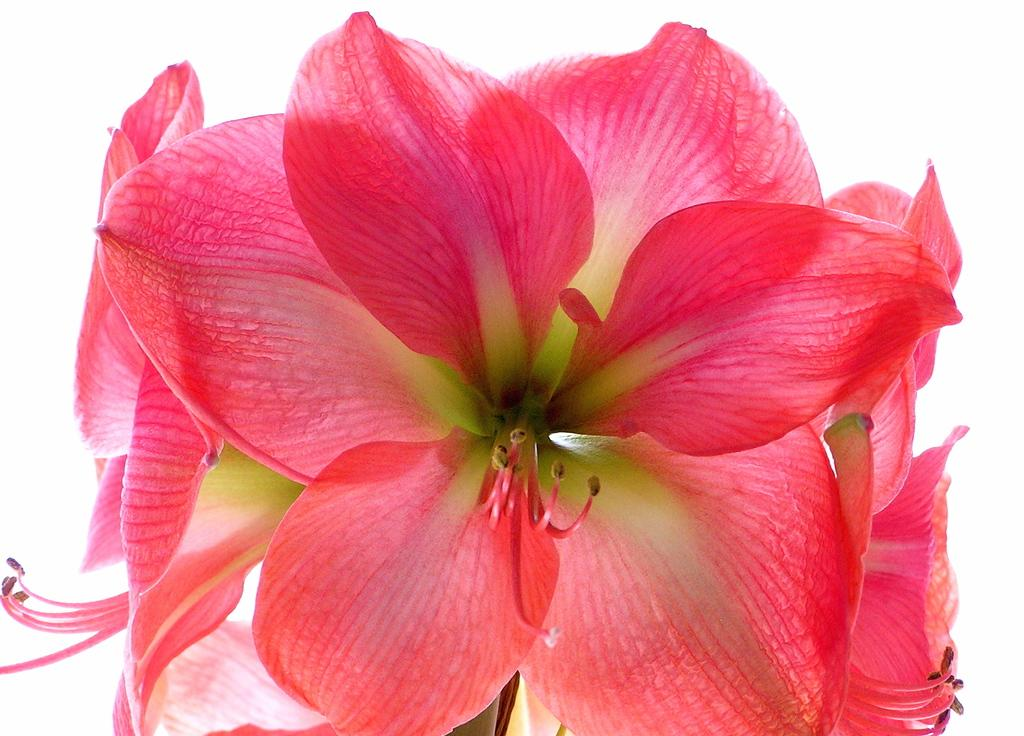What type of plants can be seen in the foreground of the image? There are flowers in the foreground of the image. What type of butter can be seen on the linen in the image? There is no butter or linen present in the image; it only features flowers in the foreground. 